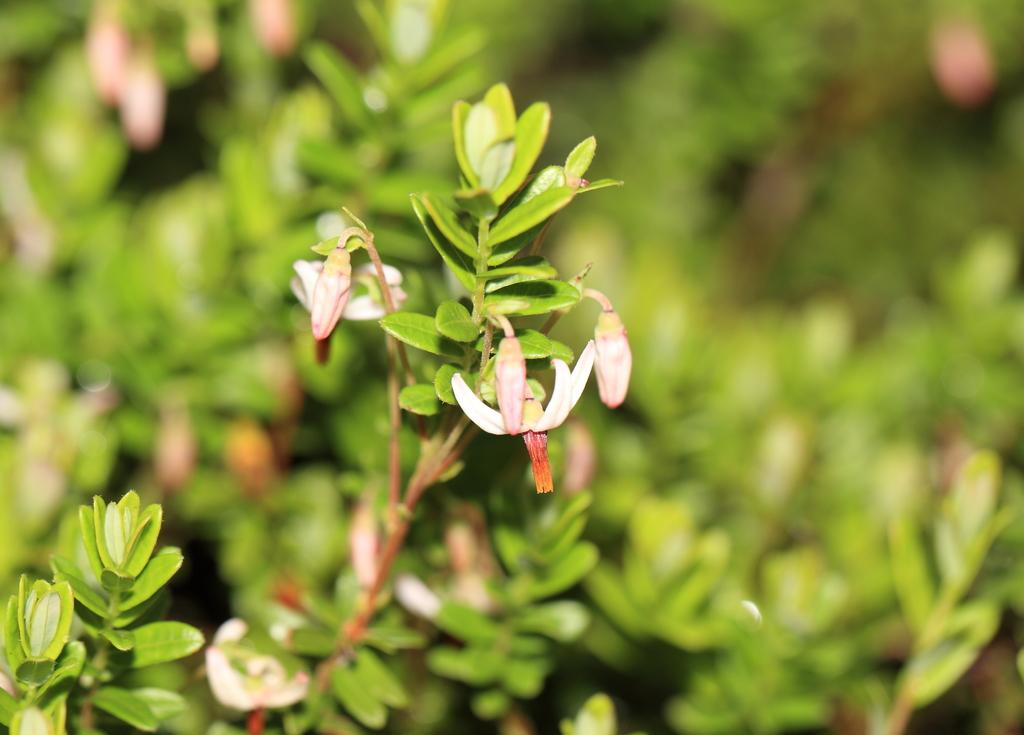What type of flowers can be seen in the image? There are flowers on a plant in the image, and they are pink in color. What can be seen in the background of the image? There are plants in the background of the image, and they are green in color. How many clocks are hanging on the jeans in the image? There are no clocks or jeans present in the image. 